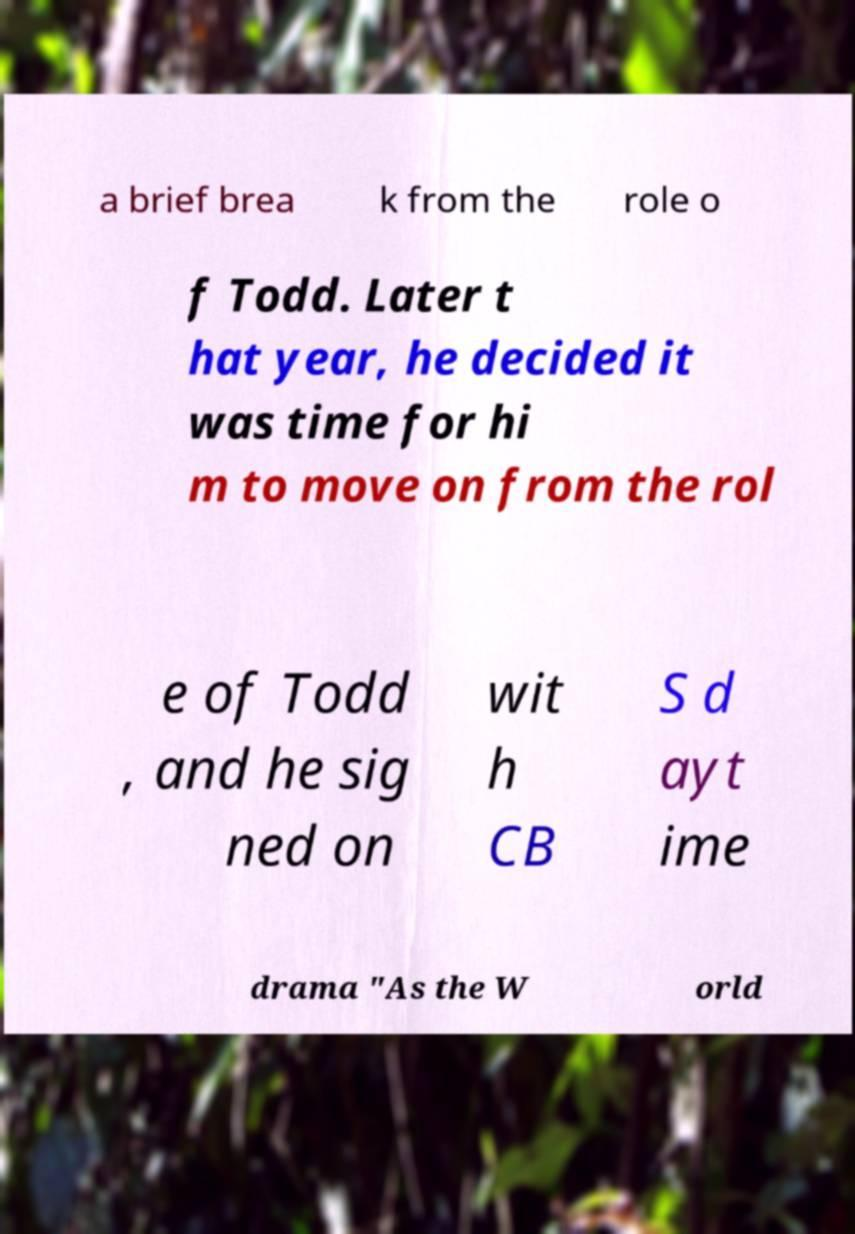Can you read and provide the text displayed in the image?This photo seems to have some interesting text. Can you extract and type it out for me? a brief brea k from the role o f Todd. Later t hat year, he decided it was time for hi m to move on from the rol e of Todd , and he sig ned on wit h CB S d ayt ime drama "As the W orld 